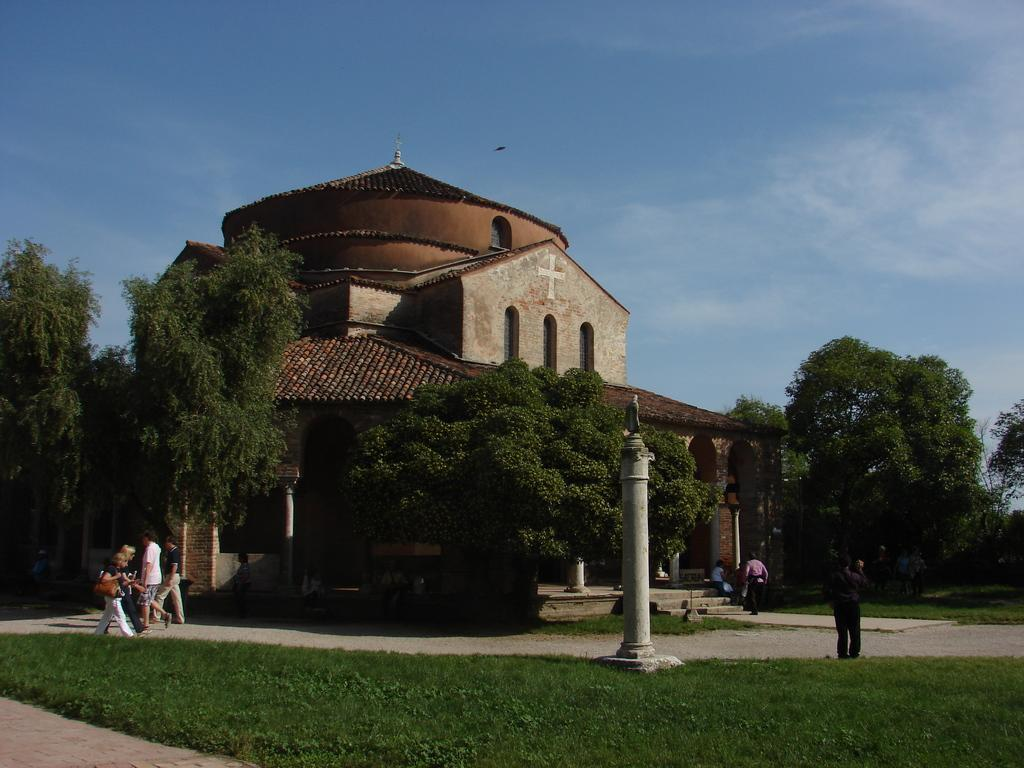What type of vegetation can be seen in the image? There is grass in the image. What type of structure is present in the image? There is a building in the image. What architectural feature is visible in the image? There are steps in the image. What are the poles used for in the image? The purpose of the poles is not specified in the image. What are the people in the image doing? There are people walking on the ground in the image. Can you describe the position of the person in the image? There is a person standing in the image. What can be seen in the background of the image? The sky is visible in the background of the image. What type of advertisement can be seen on the pies in the image? There are no pies or advertisements present in the image. What type of cord is being used by the person standing in the image? There is no cord visible in the image; the person standing is not holding or using any cord. 